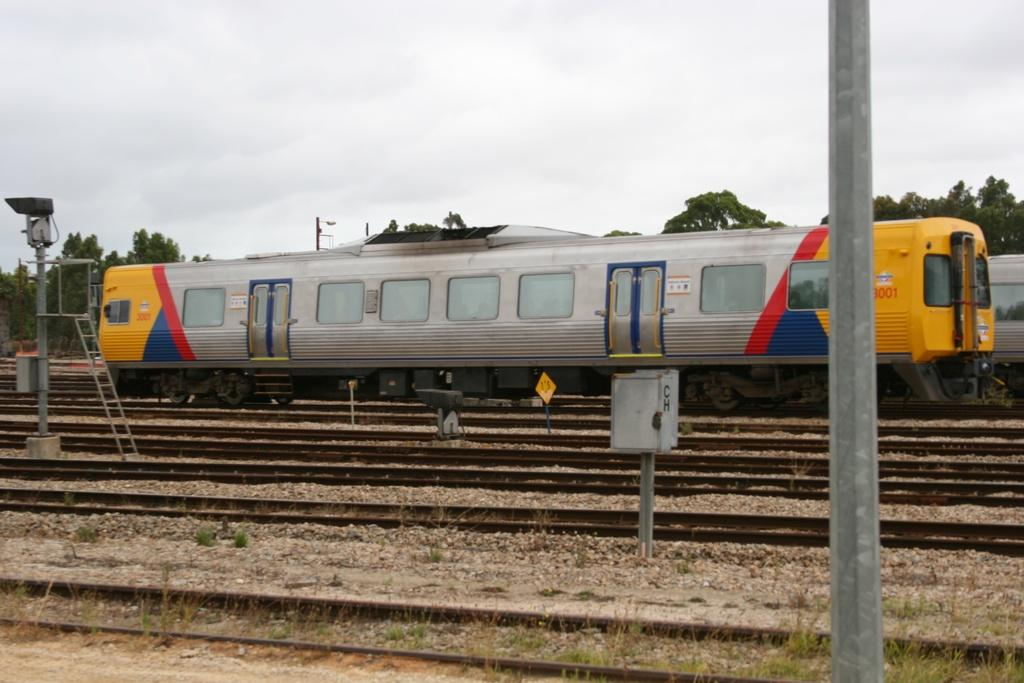What is the main subject of the image? The main subject of the image is a train. Where is the train located in the image? The train is on a track in the image. What can be seen in the background of the image? There are trees visible in the background of the image. What else is visible in the image? The sky is visible in the image. What type of insurance does the train have in the image? There is no information about insurance in the image, as it features a train on a track with trees and sky in the background. 